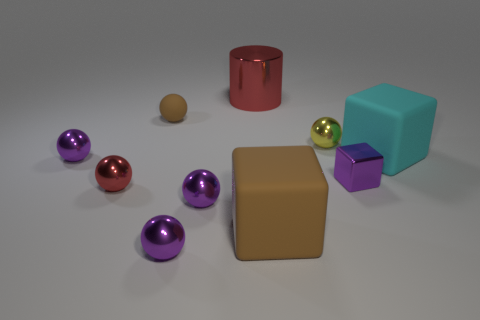Are there fewer purple shiny cubes than tiny purple metal things?
Your answer should be compact. Yes. How many balls are big cyan rubber things or tiny yellow objects?
Your response must be concise. 1. How many big cubes are the same color as the small rubber sphere?
Your answer should be very brief. 1. There is a object that is both on the left side of the small yellow metal thing and to the right of the cylinder; what size is it?
Offer a very short reply. Large. Are there fewer big brown matte things that are right of the large cyan object than brown things?
Your answer should be very brief. Yes. Is the cyan object made of the same material as the cylinder?
Make the answer very short. No. How many objects are large cyan cubes or purple metal spheres?
Provide a short and direct response. 4. How many objects have the same material as the yellow ball?
Give a very brief answer. 6. The brown thing that is the same shape as the large cyan matte thing is what size?
Your answer should be very brief. Large. There is a red cylinder; are there any tiny cubes behind it?
Your response must be concise. No. 